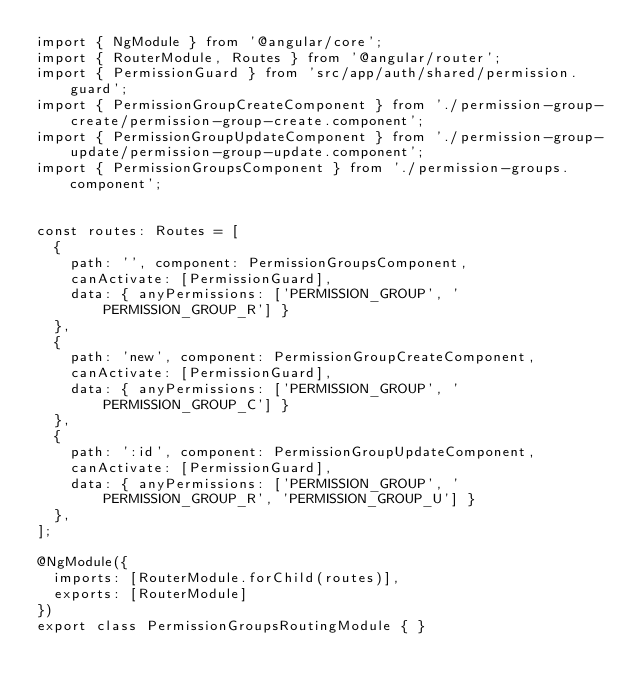Convert code to text. <code><loc_0><loc_0><loc_500><loc_500><_TypeScript_>import { NgModule } from '@angular/core';
import { RouterModule, Routes } from '@angular/router';
import { PermissionGuard } from 'src/app/auth/shared/permission.guard';
import { PermissionGroupCreateComponent } from './permission-group-create/permission-group-create.component';
import { PermissionGroupUpdateComponent } from './permission-group-update/permission-group-update.component';
import { PermissionGroupsComponent } from './permission-groups.component';


const routes: Routes = [
  {
    path: '', component: PermissionGroupsComponent,
    canActivate: [PermissionGuard],
    data: { anyPermissions: ['PERMISSION_GROUP', 'PERMISSION_GROUP_R'] }
  },
  {
    path: 'new', component: PermissionGroupCreateComponent,
    canActivate: [PermissionGuard],
    data: { anyPermissions: ['PERMISSION_GROUP', 'PERMISSION_GROUP_C'] }
  },
  {
    path: ':id', component: PermissionGroupUpdateComponent,
    canActivate: [PermissionGuard],
    data: { anyPermissions: ['PERMISSION_GROUP', 'PERMISSION_GROUP_R', 'PERMISSION_GROUP_U'] }
  },
];

@NgModule({
  imports: [RouterModule.forChild(routes)],
  exports: [RouterModule]
})
export class PermissionGroupsRoutingModule { }
</code> 